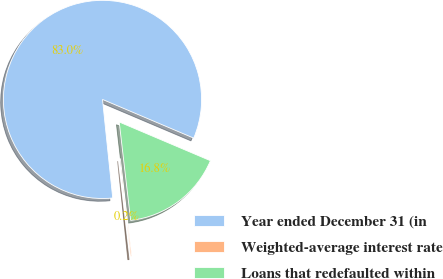<chart> <loc_0><loc_0><loc_500><loc_500><pie_chart><fcel>Year ended December 31 (in<fcel>Weighted-average interest rate<fcel>Loans that redefaulted within<nl><fcel>83.03%<fcel>0.2%<fcel>16.77%<nl></chart> 